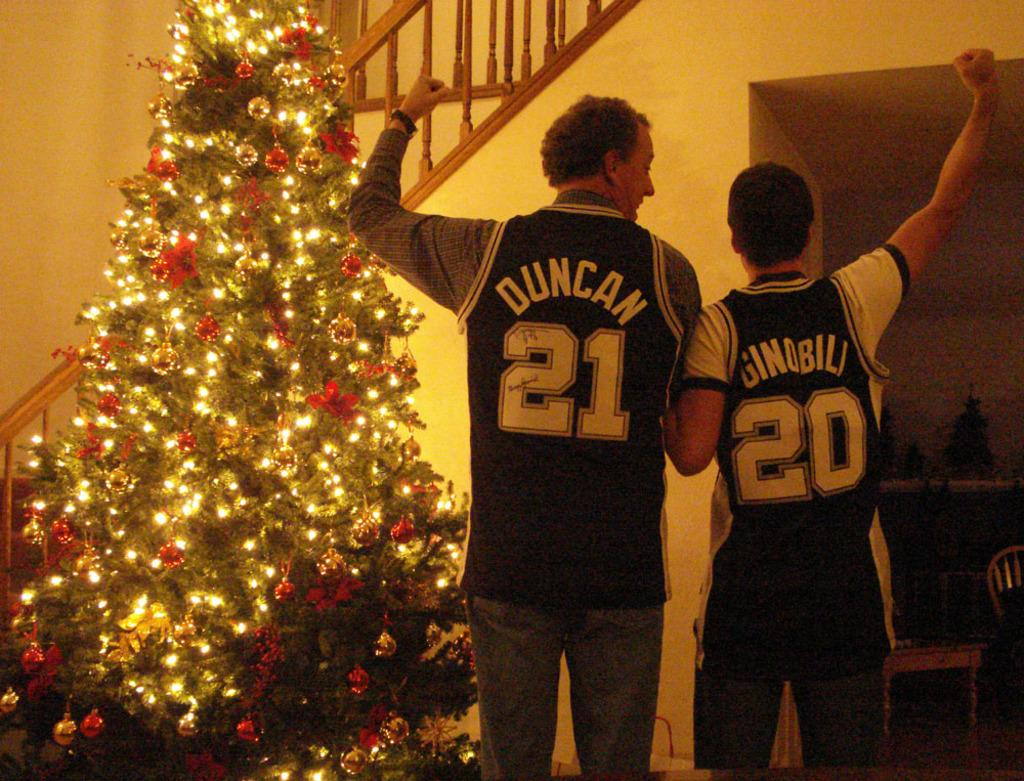<image>
Share a concise interpretation of the image provided. Two men and a Christmas tree, one of the men having Duncan 21 on the back of his shirt. 